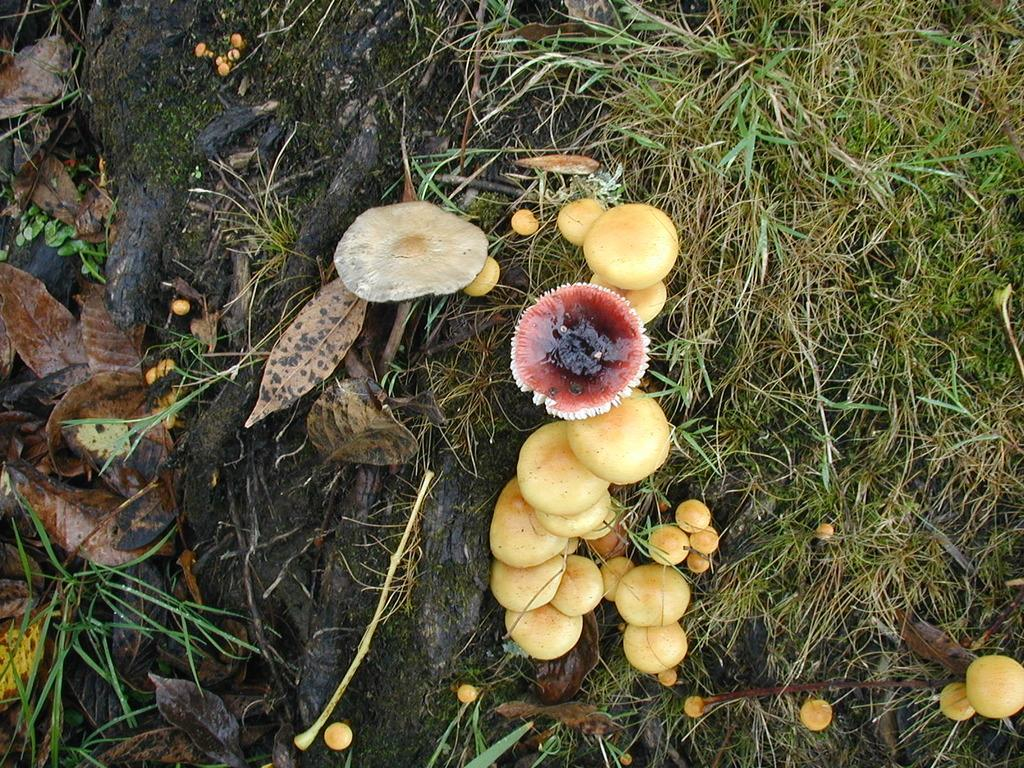What types of fungi can be seen in the image? There are different types of mushrooms in the image. What type of vegetation is present in the image? There is green grass in the image. What other natural elements can be seen in the image? Branches are visible in the image. What additional details can be observed in the image? Dried leaves are present in the image. What type of fruit can be seen in the bedroom in the image? There is no fruit or bedroom present in the image; it features mushrooms, green grass, branches, and dried leaves. 